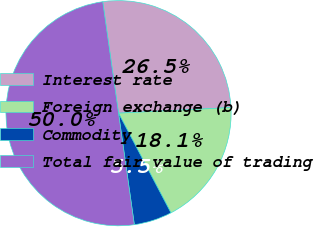Convert chart to OTSL. <chart><loc_0><loc_0><loc_500><loc_500><pie_chart><fcel>Interest rate<fcel>Foreign exchange (b)<fcel>Commodity<fcel>Total fair value of trading<nl><fcel>26.45%<fcel>18.09%<fcel>5.46%<fcel>50.0%<nl></chart> 